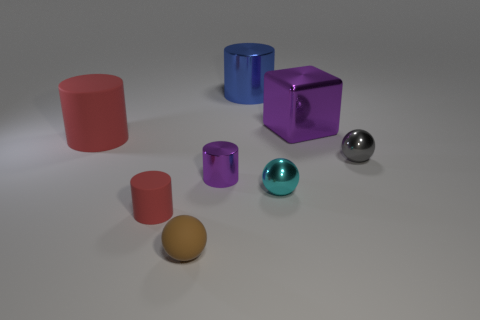Subtract all purple cylinders. How many cylinders are left? 3 Subtract 1 cylinders. How many cylinders are left? 3 Subtract all small rubber cylinders. How many cylinders are left? 3 Add 2 small purple blocks. How many objects exist? 10 Subtract all cyan cylinders. Subtract all red cubes. How many cylinders are left? 4 Subtract all balls. How many objects are left? 5 Subtract all big gray shiny cubes. Subtract all tiny gray metallic spheres. How many objects are left? 7 Add 1 brown balls. How many brown balls are left? 2 Add 1 big cyan rubber spheres. How many big cyan rubber spheres exist? 1 Subtract 0 blue spheres. How many objects are left? 8 